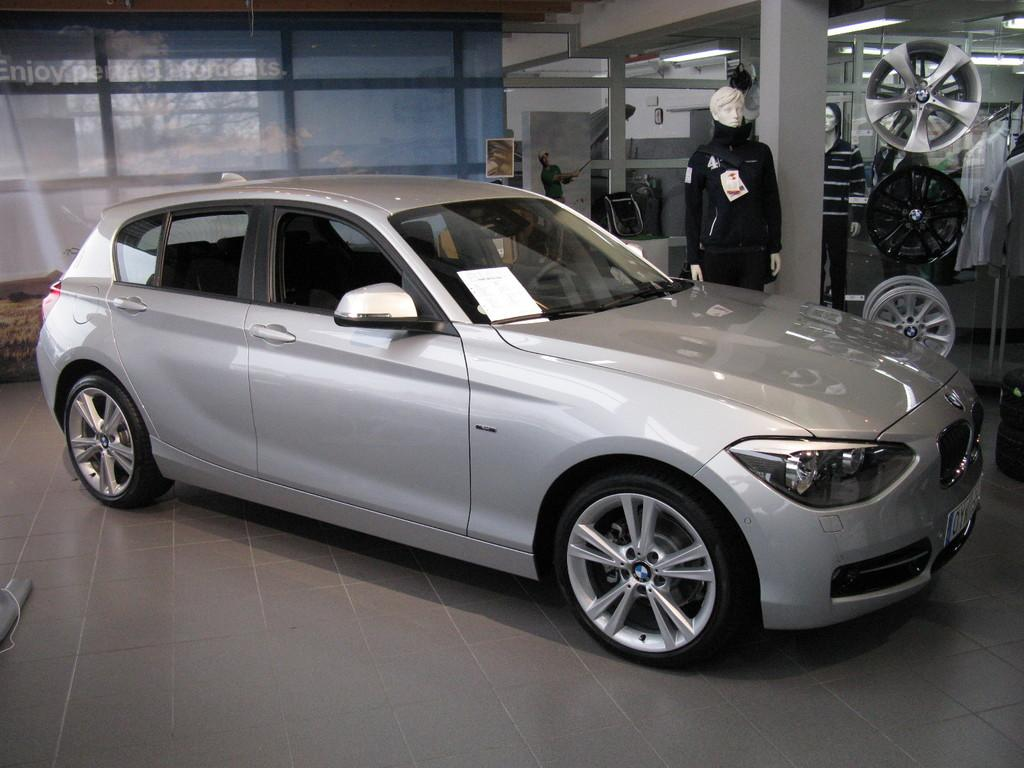What is the main object in the image? There is a car in the image. Where is the car located? The car is on the floor. What else can be seen on the right side of the image? There is a mannequin and wheels visible on the right side of the image. What type of wax is being used to create the oatmeal texture on the houses in the image? There are no houses or oatmeal texture present in the image. 